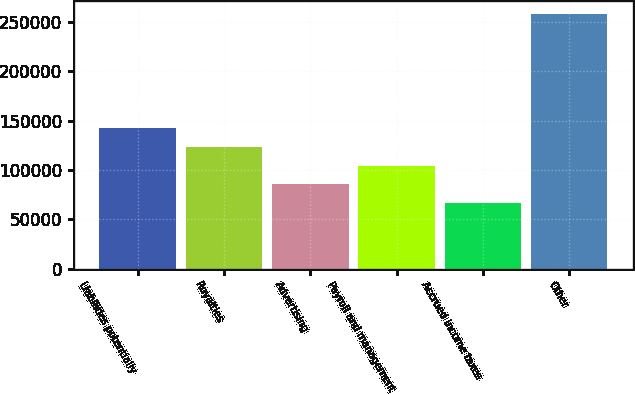<chart> <loc_0><loc_0><loc_500><loc_500><bar_chart><fcel>Liabilities potentially<fcel>Royalties<fcel>Advertising<fcel>Payroll and management<fcel>Accrued income taxes<fcel>Other<nl><fcel>143051<fcel>123808<fcel>85322.7<fcel>104565<fcel>66080<fcel>258507<nl></chart> 